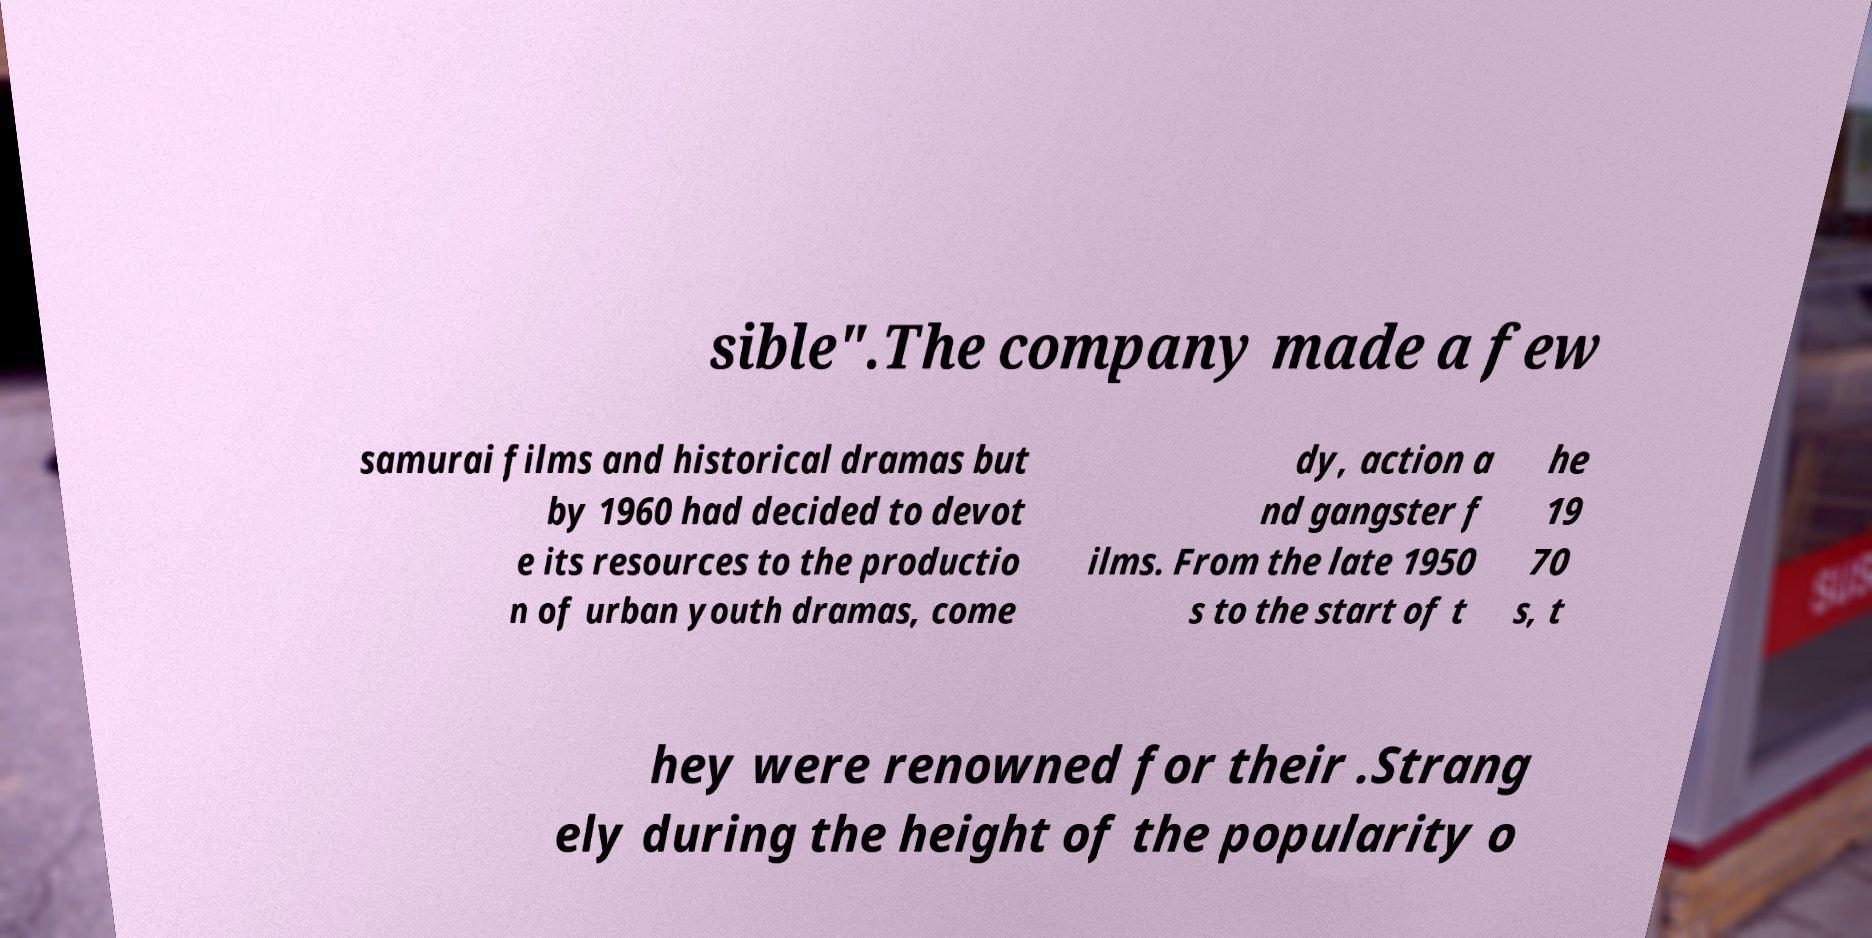There's text embedded in this image that I need extracted. Can you transcribe it verbatim? sible".The company made a few samurai films and historical dramas but by 1960 had decided to devot e its resources to the productio n of urban youth dramas, come dy, action a nd gangster f ilms. From the late 1950 s to the start of t he 19 70 s, t hey were renowned for their .Strang ely during the height of the popularity o 